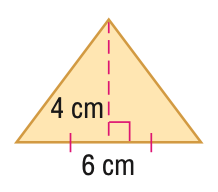Answer the mathemtical geometry problem and directly provide the correct option letter.
Question: Find the area of the figure. Round to the nearest tenth.
Choices: A: 12 B: 16 C: 18 D: 24 A 